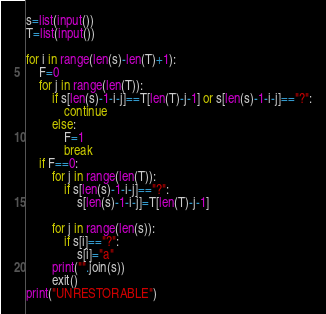Convert code to text. <code><loc_0><loc_0><loc_500><loc_500><_Python_>s=list(input())
T=list(input())

for i in range(len(s)-len(T)+1):
    F=0
    for j in range(len(T)):
        if s[len(s)-1-i-j]==T[len(T)-j-1] or s[len(s)-1-i-j]=="?":
            continue
        else:
            F=1
            break
    if F==0:
        for j in range(len(T)):
            if s[len(s)-1-i-j]=="?":
                s[len(s)-1-i-j]=T[len(T)-j-1]
        
        for j in range(len(s)):
            if s[i]=="?":
                s[i]="a"
        print("".join(s))
        exit()
print("UNRESTORABLE")
</code> 